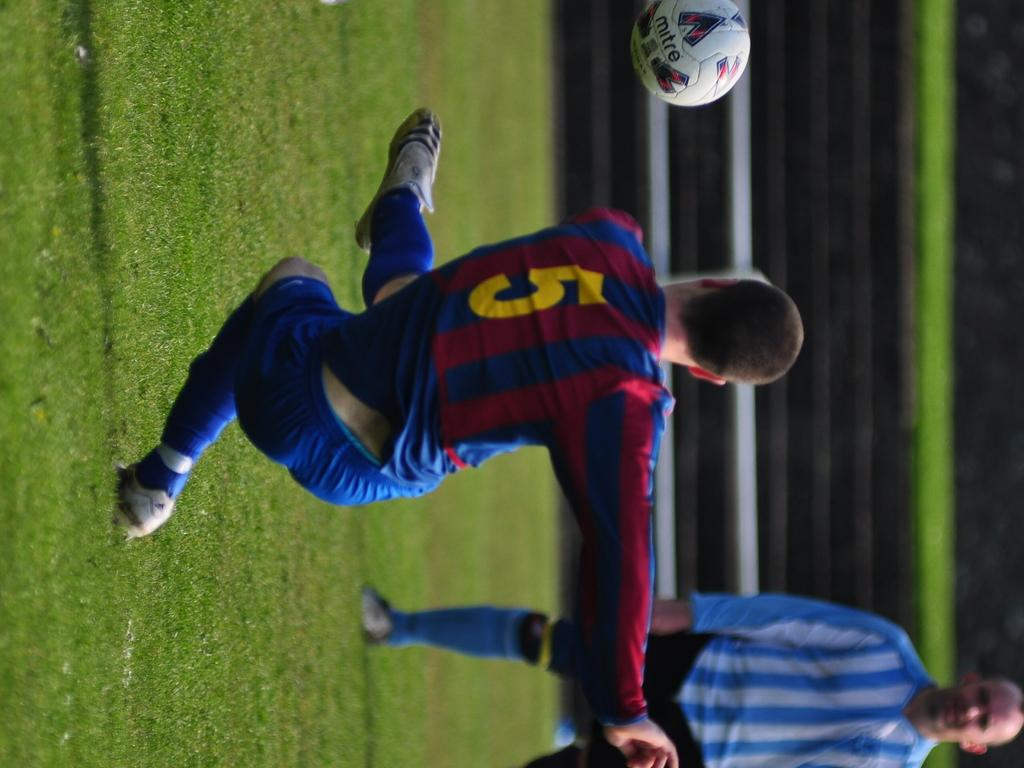How many people are playing in the image? There are two players in the image. What surface are the players on? The players are playing on a ground. What sport are the players engaged in? The players are playing with a football, so they are likely playing football. Can you describe the background of the image? The background of the image is blurred. Where is the shelf located in the image? There is no shelf present in the image. What type of glove is the player wearing in the image? The players are not wearing gloves in the image; they are playing football, which typically does not involve gloves. 